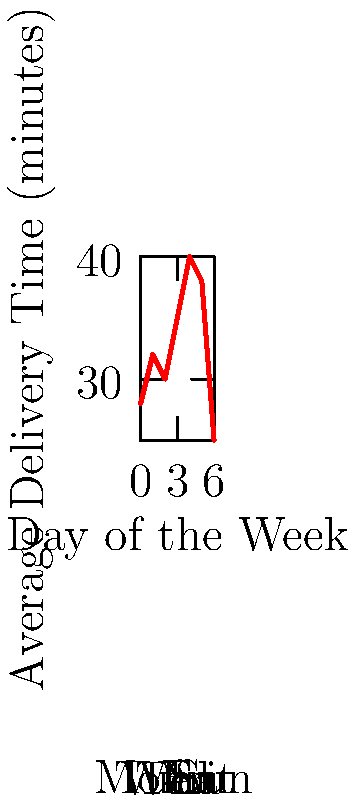Based on the line graph showing average delivery times over different days of the week, which day has the longest average delivery time, and what potential factors might contribute to this peak? To answer this question, we need to analyze the line graph and follow these steps:

1. Identify the highest point on the graph:
   The graph shows that Friday (day 5) has the highest peak, indicating the longest average delivery time.

2. Determine the average delivery time for Friday:
   The y-axis shows that the average delivery time on Friday is 40 minutes.

3. Consider potential factors contributing to this peak:
   a) Higher order volume: Fridays often see increased restaurant orders as people celebrate the end of the work week.
   b) Traffic congestion: Many cities experience heavier traffic on Friday evenings as people leave work and start their weekend activities.
   c) Staff scheduling: There might be a mismatch between the number of delivery drivers scheduled and the increased demand.
   d) Kitchen capacity: The restaurant's kitchen may struggle to keep up with the higher order volume, causing delays in food preparation.

4. Compare Friday to other days:
   The graph shows a general upward trend from Monday to Friday, with a significant drop on weekends. This pattern suggests that weekday factors, particularly those intensifying towards the end of the work week, play a crucial role in delivery times.

5. Consider operational implications:
   As a logistics specialist, this information can be used to optimize delivery operations, such as increasing staff on Fridays, implementing more efficient routing systems, or working with the kitchen to streamline food preparation during peak times.
Answer: Friday; 40 minutes; likely due to higher order volume and traffic congestion. 